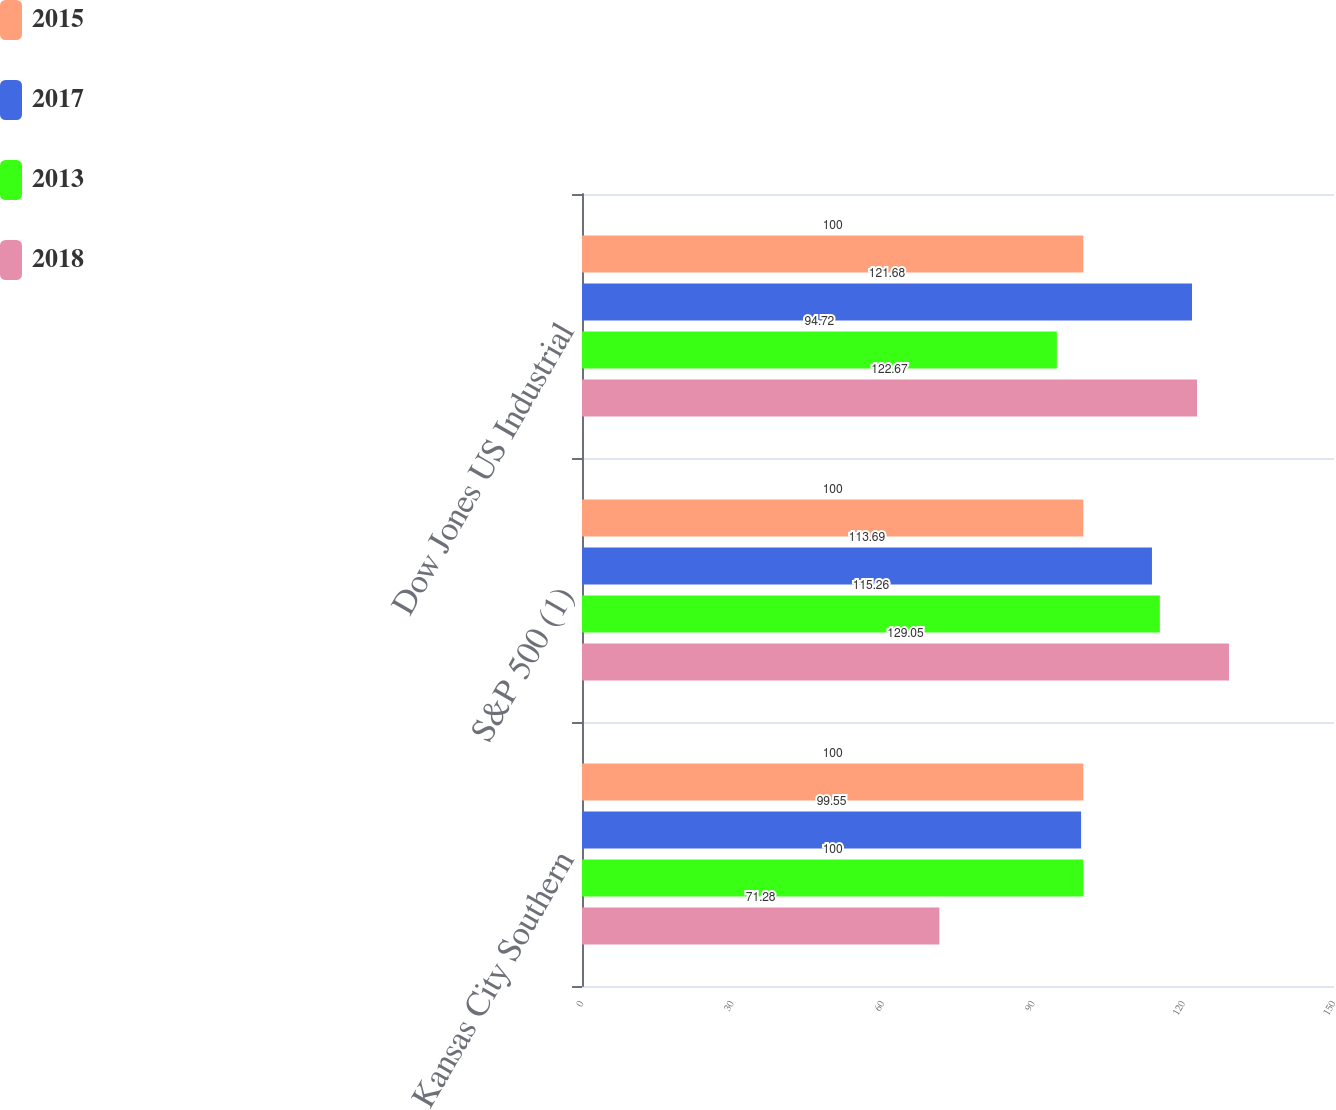Convert chart to OTSL. <chart><loc_0><loc_0><loc_500><loc_500><stacked_bar_chart><ecel><fcel>Kansas City Southern<fcel>S&P 500 (1)<fcel>Dow Jones US Industrial<nl><fcel>2015<fcel>100<fcel>100<fcel>100<nl><fcel>2017<fcel>99.55<fcel>113.69<fcel>121.68<nl><fcel>2013<fcel>100<fcel>115.26<fcel>94.72<nl><fcel>2018<fcel>71.28<fcel>129.05<fcel>122.67<nl></chart> 